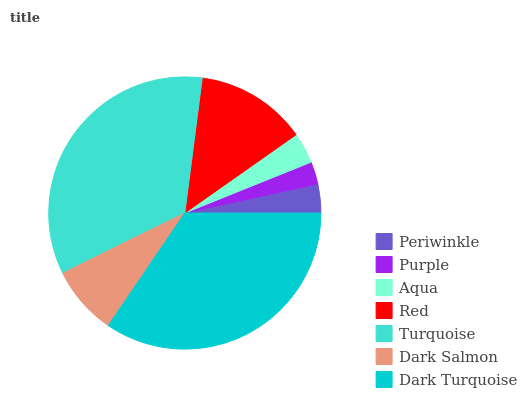Is Purple the minimum?
Answer yes or no. Yes. Is Dark Turquoise the maximum?
Answer yes or no. Yes. Is Aqua the minimum?
Answer yes or no. No. Is Aqua the maximum?
Answer yes or no. No. Is Aqua greater than Purple?
Answer yes or no. Yes. Is Purple less than Aqua?
Answer yes or no. Yes. Is Purple greater than Aqua?
Answer yes or no. No. Is Aqua less than Purple?
Answer yes or no. No. Is Dark Salmon the high median?
Answer yes or no. Yes. Is Dark Salmon the low median?
Answer yes or no. Yes. Is Turquoise the high median?
Answer yes or no. No. Is Aqua the low median?
Answer yes or no. No. 